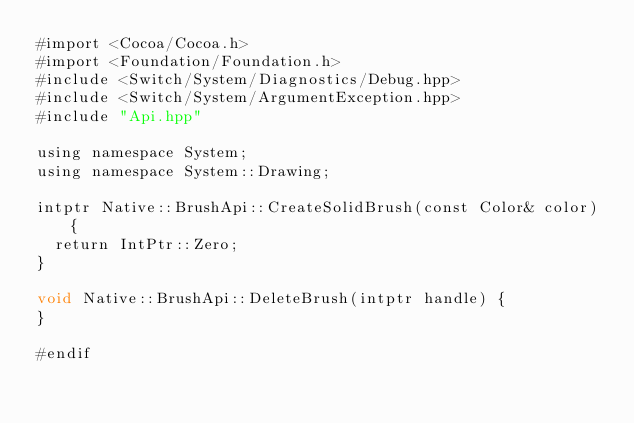<code> <loc_0><loc_0><loc_500><loc_500><_ObjectiveC_>#import <Cocoa/Cocoa.h>
#import <Foundation/Foundation.h>
#include <Switch/System/Diagnostics/Debug.hpp>
#include <Switch/System/ArgumentException.hpp>
#include "Api.hpp"

using namespace System;
using namespace System::Drawing;

intptr Native::BrushApi::CreateSolidBrush(const Color& color) {
  return IntPtr::Zero;
}

void Native::BrushApi::DeleteBrush(intptr handle) {
}

#endif
</code> 